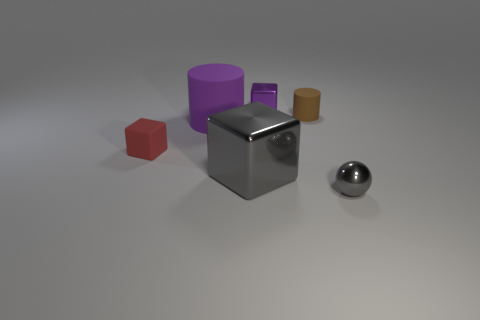Is there any other thing that has the same size as the purple metallic object?
Your answer should be compact. Yes. What is the color of the tiny cylinder that is the same material as the small red cube?
Ensure brevity in your answer.  Brown. How many blocks are either tiny cyan matte objects or rubber things?
Offer a very short reply. 1. How many things are either tiny gray metallic things or cubes behind the big gray object?
Offer a terse response. 3. Are any big green things visible?
Offer a very short reply. No. How many big metallic objects are the same color as the big matte cylinder?
Your answer should be very brief. 0. There is a small object that is the same color as the big metallic object; what is it made of?
Your response must be concise. Metal. How big is the metallic thing that is on the left side of the small metal thing behind the gray ball?
Your response must be concise. Large. Are there any big cylinders that have the same material as the tiny brown thing?
Ensure brevity in your answer.  Yes. What material is the purple object that is the same size as the gray metal block?
Make the answer very short. Rubber. 